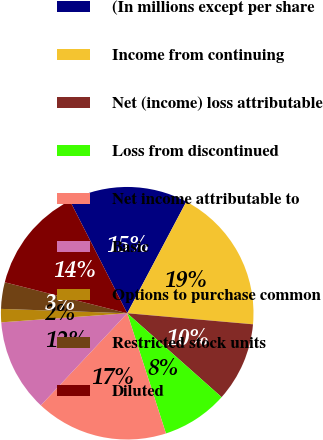Convert chart to OTSL. <chart><loc_0><loc_0><loc_500><loc_500><pie_chart><fcel>(In millions except per share<fcel>Income from continuing<fcel>Net (income) loss attributable<fcel>Loss from discontinued<fcel>Net income attributable to<fcel>Basic<fcel>Options to purchase common<fcel>Restricted stock units<fcel>Diluted<nl><fcel>15.25%<fcel>18.64%<fcel>10.17%<fcel>8.47%<fcel>16.95%<fcel>11.86%<fcel>1.7%<fcel>3.39%<fcel>13.56%<nl></chart> 